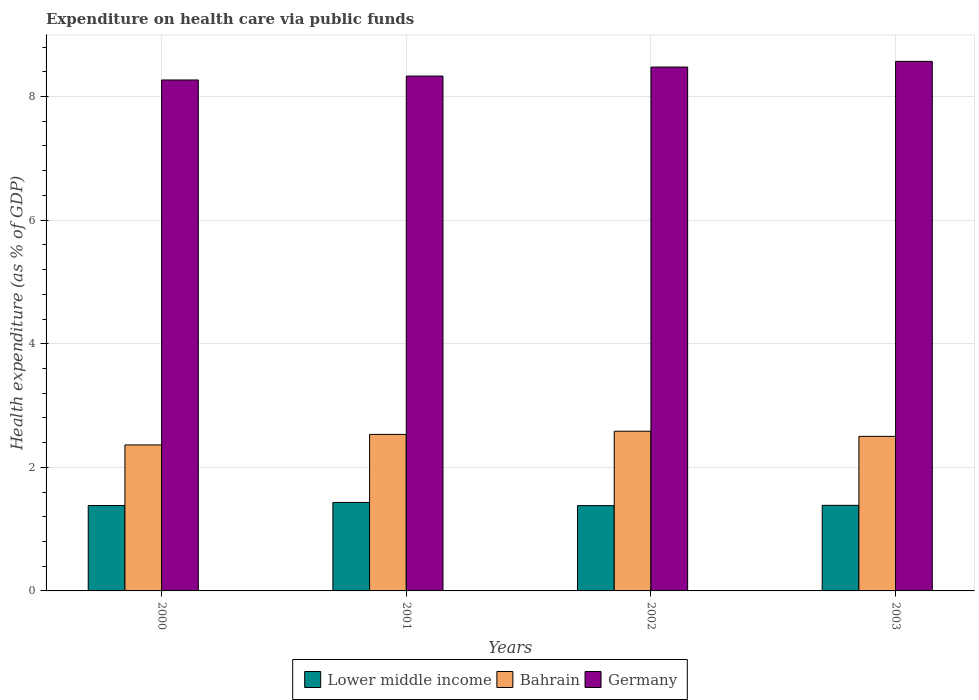How many different coloured bars are there?
Your answer should be compact. 3. Are the number of bars on each tick of the X-axis equal?
Ensure brevity in your answer.  Yes. How many bars are there on the 4th tick from the right?
Your answer should be very brief. 3. What is the expenditure made on health care in Bahrain in 2002?
Your answer should be very brief. 2.58. Across all years, what is the maximum expenditure made on health care in Germany?
Your response must be concise. 8.57. Across all years, what is the minimum expenditure made on health care in Bahrain?
Make the answer very short. 2.36. In which year was the expenditure made on health care in Lower middle income minimum?
Offer a terse response. 2002. What is the total expenditure made on health care in Germany in the graph?
Your answer should be compact. 33.65. What is the difference between the expenditure made on health care in Lower middle income in 2001 and that in 2002?
Your answer should be very brief. 0.05. What is the difference between the expenditure made on health care in Lower middle income in 2000 and the expenditure made on health care in Germany in 2002?
Provide a succinct answer. -7.1. What is the average expenditure made on health care in Bahrain per year?
Give a very brief answer. 2.5. In the year 2003, what is the difference between the expenditure made on health care in Bahrain and expenditure made on health care in Lower middle income?
Your response must be concise. 1.12. What is the ratio of the expenditure made on health care in Lower middle income in 2000 to that in 2003?
Your response must be concise. 1. Is the difference between the expenditure made on health care in Bahrain in 2001 and 2003 greater than the difference between the expenditure made on health care in Lower middle income in 2001 and 2003?
Your response must be concise. No. What is the difference between the highest and the second highest expenditure made on health care in Lower middle income?
Provide a succinct answer. 0.05. What is the difference between the highest and the lowest expenditure made on health care in Bahrain?
Your answer should be compact. 0.22. Is the sum of the expenditure made on health care in Bahrain in 2001 and 2003 greater than the maximum expenditure made on health care in Lower middle income across all years?
Keep it short and to the point. Yes. Is it the case that in every year, the sum of the expenditure made on health care in Germany and expenditure made on health care in Lower middle income is greater than the expenditure made on health care in Bahrain?
Give a very brief answer. Yes. How many bars are there?
Provide a short and direct response. 12. How many years are there in the graph?
Offer a terse response. 4. What is the difference between two consecutive major ticks on the Y-axis?
Your response must be concise. 2. How are the legend labels stacked?
Give a very brief answer. Horizontal. What is the title of the graph?
Give a very brief answer. Expenditure on health care via public funds. Does "Lower middle income" appear as one of the legend labels in the graph?
Provide a short and direct response. Yes. What is the label or title of the X-axis?
Give a very brief answer. Years. What is the label or title of the Y-axis?
Ensure brevity in your answer.  Health expenditure (as % of GDP). What is the Health expenditure (as % of GDP) in Lower middle income in 2000?
Provide a short and direct response. 1.38. What is the Health expenditure (as % of GDP) in Bahrain in 2000?
Ensure brevity in your answer.  2.36. What is the Health expenditure (as % of GDP) in Germany in 2000?
Offer a very short reply. 8.27. What is the Health expenditure (as % of GDP) of Lower middle income in 2001?
Ensure brevity in your answer.  1.43. What is the Health expenditure (as % of GDP) in Bahrain in 2001?
Your answer should be compact. 2.53. What is the Health expenditure (as % of GDP) in Germany in 2001?
Make the answer very short. 8.33. What is the Health expenditure (as % of GDP) of Lower middle income in 2002?
Ensure brevity in your answer.  1.38. What is the Health expenditure (as % of GDP) of Bahrain in 2002?
Offer a very short reply. 2.58. What is the Health expenditure (as % of GDP) of Germany in 2002?
Keep it short and to the point. 8.48. What is the Health expenditure (as % of GDP) in Lower middle income in 2003?
Your answer should be very brief. 1.38. What is the Health expenditure (as % of GDP) in Bahrain in 2003?
Provide a short and direct response. 2.5. What is the Health expenditure (as % of GDP) in Germany in 2003?
Give a very brief answer. 8.57. Across all years, what is the maximum Health expenditure (as % of GDP) of Lower middle income?
Ensure brevity in your answer.  1.43. Across all years, what is the maximum Health expenditure (as % of GDP) in Bahrain?
Your answer should be compact. 2.58. Across all years, what is the maximum Health expenditure (as % of GDP) in Germany?
Your response must be concise. 8.57. Across all years, what is the minimum Health expenditure (as % of GDP) in Lower middle income?
Make the answer very short. 1.38. Across all years, what is the minimum Health expenditure (as % of GDP) in Bahrain?
Keep it short and to the point. 2.36. Across all years, what is the minimum Health expenditure (as % of GDP) of Germany?
Your answer should be compact. 8.27. What is the total Health expenditure (as % of GDP) in Lower middle income in the graph?
Provide a short and direct response. 5.58. What is the total Health expenditure (as % of GDP) in Bahrain in the graph?
Offer a terse response. 9.98. What is the total Health expenditure (as % of GDP) of Germany in the graph?
Your answer should be very brief. 33.65. What is the difference between the Health expenditure (as % of GDP) of Lower middle income in 2000 and that in 2001?
Provide a short and direct response. -0.05. What is the difference between the Health expenditure (as % of GDP) in Bahrain in 2000 and that in 2001?
Offer a very short reply. -0.17. What is the difference between the Health expenditure (as % of GDP) of Germany in 2000 and that in 2001?
Your answer should be compact. -0.06. What is the difference between the Health expenditure (as % of GDP) of Lower middle income in 2000 and that in 2002?
Give a very brief answer. 0. What is the difference between the Health expenditure (as % of GDP) of Bahrain in 2000 and that in 2002?
Your response must be concise. -0.22. What is the difference between the Health expenditure (as % of GDP) of Germany in 2000 and that in 2002?
Ensure brevity in your answer.  -0.21. What is the difference between the Health expenditure (as % of GDP) of Lower middle income in 2000 and that in 2003?
Make the answer very short. -0. What is the difference between the Health expenditure (as % of GDP) of Bahrain in 2000 and that in 2003?
Keep it short and to the point. -0.14. What is the difference between the Health expenditure (as % of GDP) of Germany in 2000 and that in 2003?
Offer a terse response. -0.3. What is the difference between the Health expenditure (as % of GDP) of Lower middle income in 2001 and that in 2002?
Make the answer very short. 0.05. What is the difference between the Health expenditure (as % of GDP) in Bahrain in 2001 and that in 2002?
Your answer should be very brief. -0.05. What is the difference between the Health expenditure (as % of GDP) in Germany in 2001 and that in 2002?
Give a very brief answer. -0.15. What is the difference between the Health expenditure (as % of GDP) in Lower middle income in 2001 and that in 2003?
Keep it short and to the point. 0.05. What is the difference between the Health expenditure (as % of GDP) of Bahrain in 2001 and that in 2003?
Your answer should be very brief. 0.03. What is the difference between the Health expenditure (as % of GDP) in Germany in 2001 and that in 2003?
Provide a succinct answer. -0.24. What is the difference between the Health expenditure (as % of GDP) of Lower middle income in 2002 and that in 2003?
Your response must be concise. -0. What is the difference between the Health expenditure (as % of GDP) in Bahrain in 2002 and that in 2003?
Your response must be concise. 0.08. What is the difference between the Health expenditure (as % of GDP) in Germany in 2002 and that in 2003?
Make the answer very short. -0.09. What is the difference between the Health expenditure (as % of GDP) of Lower middle income in 2000 and the Health expenditure (as % of GDP) of Bahrain in 2001?
Your answer should be compact. -1.15. What is the difference between the Health expenditure (as % of GDP) of Lower middle income in 2000 and the Health expenditure (as % of GDP) of Germany in 2001?
Your answer should be compact. -6.95. What is the difference between the Health expenditure (as % of GDP) of Bahrain in 2000 and the Health expenditure (as % of GDP) of Germany in 2001?
Keep it short and to the point. -5.97. What is the difference between the Health expenditure (as % of GDP) in Lower middle income in 2000 and the Health expenditure (as % of GDP) in Bahrain in 2002?
Give a very brief answer. -1.2. What is the difference between the Health expenditure (as % of GDP) in Lower middle income in 2000 and the Health expenditure (as % of GDP) in Germany in 2002?
Offer a very short reply. -7.1. What is the difference between the Health expenditure (as % of GDP) of Bahrain in 2000 and the Health expenditure (as % of GDP) of Germany in 2002?
Give a very brief answer. -6.12. What is the difference between the Health expenditure (as % of GDP) in Lower middle income in 2000 and the Health expenditure (as % of GDP) in Bahrain in 2003?
Provide a short and direct response. -1.12. What is the difference between the Health expenditure (as % of GDP) of Lower middle income in 2000 and the Health expenditure (as % of GDP) of Germany in 2003?
Ensure brevity in your answer.  -7.19. What is the difference between the Health expenditure (as % of GDP) in Bahrain in 2000 and the Health expenditure (as % of GDP) in Germany in 2003?
Ensure brevity in your answer.  -6.21. What is the difference between the Health expenditure (as % of GDP) of Lower middle income in 2001 and the Health expenditure (as % of GDP) of Bahrain in 2002?
Your answer should be compact. -1.15. What is the difference between the Health expenditure (as % of GDP) of Lower middle income in 2001 and the Health expenditure (as % of GDP) of Germany in 2002?
Your answer should be very brief. -7.05. What is the difference between the Health expenditure (as % of GDP) of Bahrain in 2001 and the Health expenditure (as % of GDP) of Germany in 2002?
Give a very brief answer. -5.94. What is the difference between the Health expenditure (as % of GDP) in Lower middle income in 2001 and the Health expenditure (as % of GDP) in Bahrain in 2003?
Your answer should be compact. -1.07. What is the difference between the Health expenditure (as % of GDP) in Lower middle income in 2001 and the Health expenditure (as % of GDP) in Germany in 2003?
Your response must be concise. -7.14. What is the difference between the Health expenditure (as % of GDP) of Bahrain in 2001 and the Health expenditure (as % of GDP) of Germany in 2003?
Your answer should be very brief. -6.04. What is the difference between the Health expenditure (as % of GDP) of Lower middle income in 2002 and the Health expenditure (as % of GDP) of Bahrain in 2003?
Give a very brief answer. -1.12. What is the difference between the Health expenditure (as % of GDP) of Lower middle income in 2002 and the Health expenditure (as % of GDP) of Germany in 2003?
Your answer should be very brief. -7.19. What is the difference between the Health expenditure (as % of GDP) of Bahrain in 2002 and the Health expenditure (as % of GDP) of Germany in 2003?
Keep it short and to the point. -5.99. What is the average Health expenditure (as % of GDP) in Lower middle income per year?
Keep it short and to the point. 1.39. What is the average Health expenditure (as % of GDP) in Bahrain per year?
Keep it short and to the point. 2.5. What is the average Health expenditure (as % of GDP) in Germany per year?
Give a very brief answer. 8.41. In the year 2000, what is the difference between the Health expenditure (as % of GDP) of Lower middle income and Health expenditure (as % of GDP) of Bahrain?
Provide a short and direct response. -0.98. In the year 2000, what is the difference between the Health expenditure (as % of GDP) in Lower middle income and Health expenditure (as % of GDP) in Germany?
Your response must be concise. -6.89. In the year 2000, what is the difference between the Health expenditure (as % of GDP) in Bahrain and Health expenditure (as % of GDP) in Germany?
Give a very brief answer. -5.91. In the year 2001, what is the difference between the Health expenditure (as % of GDP) of Lower middle income and Health expenditure (as % of GDP) of Bahrain?
Your answer should be compact. -1.1. In the year 2001, what is the difference between the Health expenditure (as % of GDP) of Lower middle income and Health expenditure (as % of GDP) of Germany?
Give a very brief answer. -6.9. In the year 2001, what is the difference between the Health expenditure (as % of GDP) in Bahrain and Health expenditure (as % of GDP) in Germany?
Keep it short and to the point. -5.8. In the year 2002, what is the difference between the Health expenditure (as % of GDP) in Lower middle income and Health expenditure (as % of GDP) in Bahrain?
Your response must be concise. -1.2. In the year 2002, what is the difference between the Health expenditure (as % of GDP) of Lower middle income and Health expenditure (as % of GDP) of Germany?
Offer a terse response. -7.1. In the year 2002, what is the difference between the Health expenditure (as % of GDP) in Bahrain and Health expenditure (as % of GDP) in Germany?
Provide a succinct answer. -5.89. In the year 2003, what is the difference between the Health expenditure (as % of GDP) of Lower middle income and Health expenditure (as % of GDP) of Bahrain?
Give a very brief answer. -1.12. In the year 2003, what is the difference between the Health expenditure (as % of GDP) in Lower middle income and Health expenditure (as % of GDP) in Germany?
Ensure brevity in your answer.  -7.18. In the year 2003, what is the difference between the Health expenditure (as % of GDP) of Bahrain and Health expenditure (as % of GDP) of Germany?
Offer a very short reply. -6.07. What is the ratio of the Health expenditure (as % of GDP) of Lower middle income in 2000 to that in 2001?
Your answer should be compact. 0.97. What is the ratio of the Health expenditure (as % of GDP) in Bahrain in 2000 to that in 2001?
Provide a succinct answer. 0.93. What is the ratio of the Health expenditure (as % of GDP) in Germany in 2000 to that in 2001?
Keep it short and to the point. 0.99. What is the ratio of the Health expenditure (as % of GDP) in Bahrain in 2000 to that in 2002?
Your answer should be compact. 0.91. What is the ratio of the Health expenditure (as % of GDP) of Germany in 2000 to that in 2002?
Your answer should be very brief. 0.98. What is the ratio of the Health expenditure (as % of GDP) in Lower middle income in 2000 to that in 2003?
Provide a succinct answer. 1. What is the ratio of the Health expenditure (as % of GDP) of Bahrain in 2000 to that in 2003?
Make the answer very short. 0.94. What is the ratio of the Health expenditure (as % of GDP) of Germany in 2000 to that in 2003?
Offer a terse response. 0.96. What is the ratio of the Health expenditure (as % of GDP) of Lower middle income in 2001 to that in 2002?
Your answer should be very brief. 1.04. What is the ratio of the Health expenditure (as % of GDP) in Bahrain in 2001 to that in 2002?
Give a very brief answer. 0.98. What is the ratio of the Health expenditure (as % of GDP) of Germany in 2001 to that in 2002?
Ensure brevity in your answer.  0.98. What is the ratio of the Health expenditure (as % of GDP) of Lower middle income in 2001 to that in 2003?
Ensure brevity in your answer.  1.03. What is the ratio of the Health expenditure (as % of GDP) in Bahrain in 2001 to that in 2003?
Your response must be concise. 1.01. What is the ratio of the Health expenditure (as % of GDP) of Germany in 2001 to that in 2003?
Make the answer very short. 0.97. What is the ratio of the Health expenditure (as % of GDP) in Lower middle income in 2002 to that in 2003?
Provide a short and direct response. 1. What is the ratio of the Health expenditure (as % of GDP) in Bahrain in 2002 to that in 2003?
Give a very brief answer. 1.03. What is the ratio of the Health expenditure (as % of GDP) in Germany in 2002 to that in 2003?
Make the answer very short. 0.99. What is the difference between the highest and the second highest Health expenditure (as % of GDP) of Lower middle income?
Ensure brevity in your answer.  0.05. What is the difference between the highest and the second highest Health expenditure (as % of GDP) in Bahrain?
Ensure brevity in your answer.  0.05. What is the difference between the highest and the second highest Health expenditure (as % of GDP) of Germany?
Give a very brief answer. 0.09. What is the difference between the highest and the lowest Health expenditure (as % of GDP) in Lower middle income?
Provide a short and direct response. 0.05. What is the difference between the highest and the lowest Health expenditure (as % of GDP) in Bahrain?
Your answer should be compact. 0.22. What is the difference between the highest and the lowest Health expenditure (as % of GDP) in Germany?
Your answer should be very brief. 0.3. 